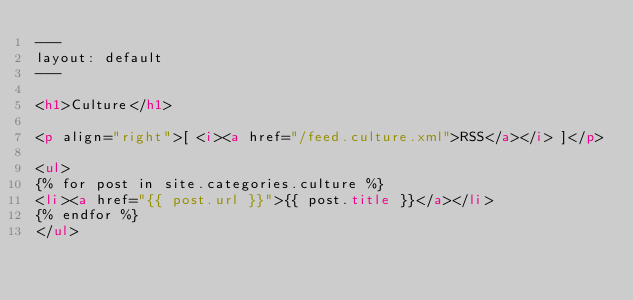Convert code to text. <code><loc_0><loc_0><loc_500><loc_500><_HTML_>---
layout: default
---

<h1>Culture</h1>

<p align="right">[ <i><a href="/feed.culture.xml">RSS</a></i> ]</p>

<ul>
{% for post in site.categories.culture %}
<li><a href="{{ post.url }}">{{ post.title }}</a></li>
{% endfor %}
</ul>

</code> 